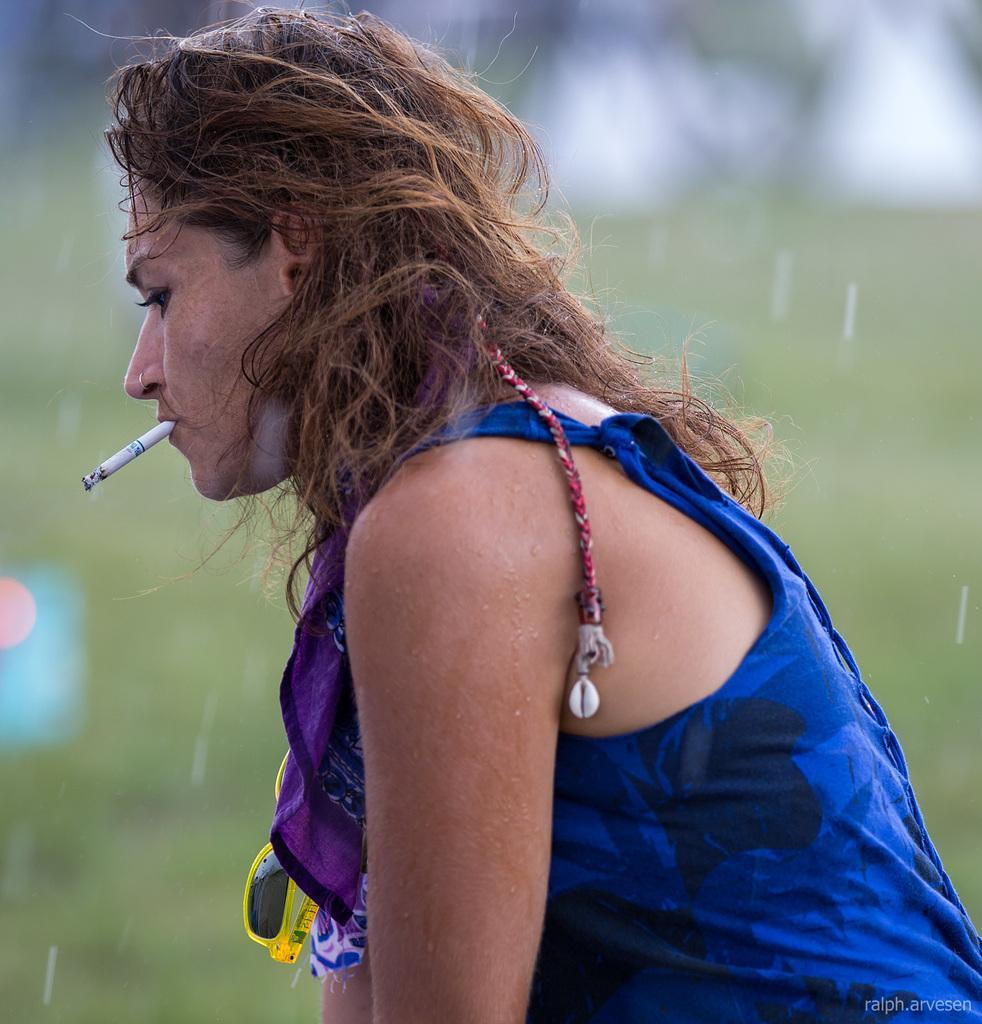Describe this image in one or two sentences. In this image in the front there is a woman smoking and the background is blurry. 